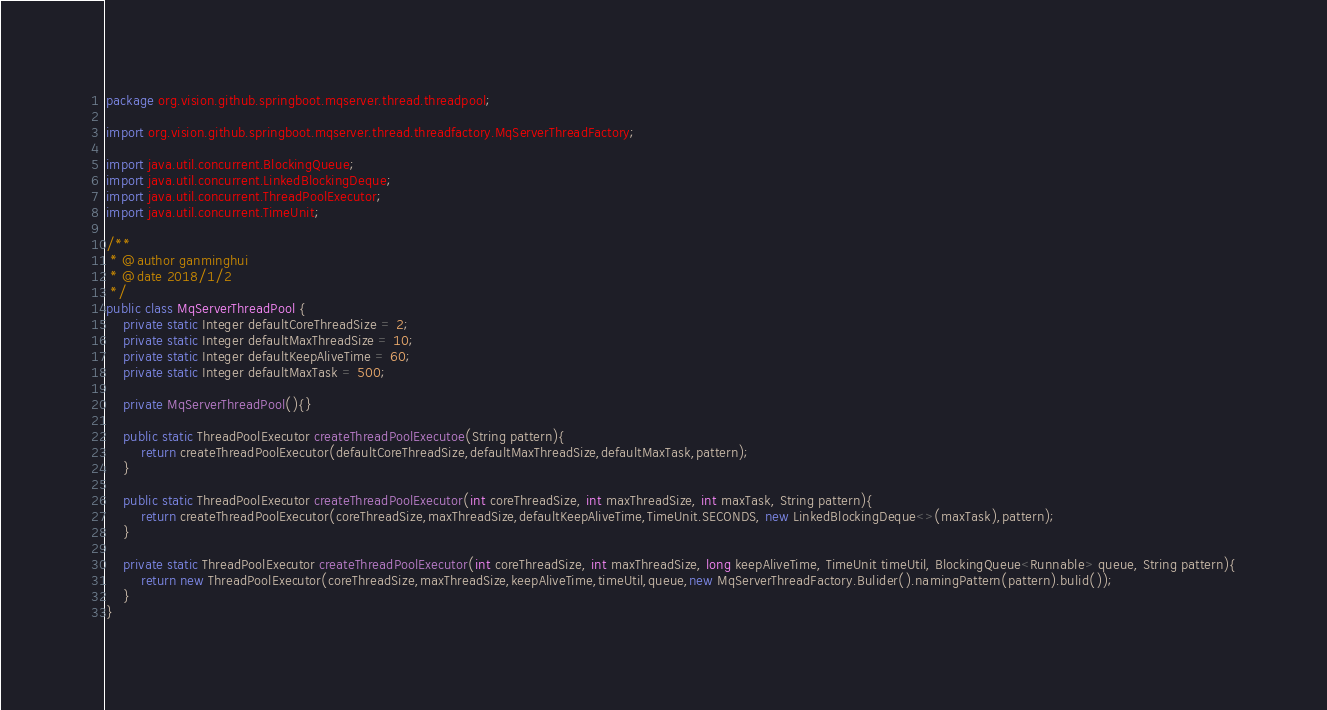Convert code to text. <code><loc_0><loc_0><loc_500><loc_500><_Java_>package org.vision.github.springboot.mqserver.thread.threadpool;

import org.vision.github.springboot.mqserver.thread.threadfactory.MqServerThreadFactory;

import java.util.concurrent.BlockingQueue;
import java.util.concurrent.LinkedBlockingDeque;
import java.util.concurrent.ThreadPoolExecutor;
import java.util.concurrent.TimeUnit;

/**
 * @author ganminghui
 * @date 2018/1/2
 */
public class MqServerThreadPool {
    private static Integer defaultCoreThreadSize = 2;
    private static Integer defaultMaxThreadSize = 10;
    private static Integer defaultKeepAliveTime = 60;
    private static Integer defaultMaxTask = 500;

    private MqServerThreadPool(){}

    public static ThreadPoolExecutor createThreadPoolExecutoe(String pattern){
        return createThreadPoolExecutor(defaultCoreThreadSize,defaultMaxThreadSize,defaultMaxTask,pattern);
    }

    public static ThreadPoolExecutor createThreadPoolExecutor(int coreThreadSize, int maxThreadSize, int maxTask, String pattern){
        return createThreadPoolExecutor(coreThreadSize,maxThreadSize,defaultKeepAliveTime,TimeUnit.SECONDS, new LinkedBlockingDeque<>(maxTask),pattern);
    }

    private static ThreadPoolExecutor createThreadPoolExecutor(int coreThreadSize, int maxThreadSize, long keepAliveTime, TimeUnit timeUtil, BlockingQueue<Runnable> queue, String pattern){
        return new ThreadPoolExecutor(coreThreadSize,maxThreadSize,keepAliveTime,timeUtil,queue,new MqServerThreadFactory.Bulider().namingPattern(pattern).bulid());
    }
}</code> 